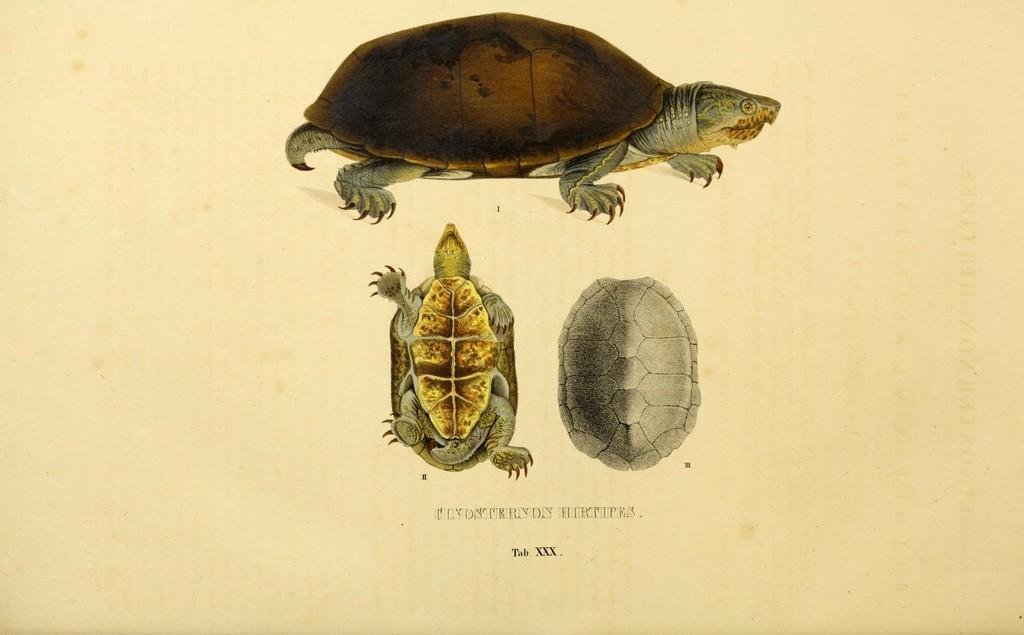In one or two sentences, can you explain what this image depicts? In this picture we can see some text and few reptile images. 